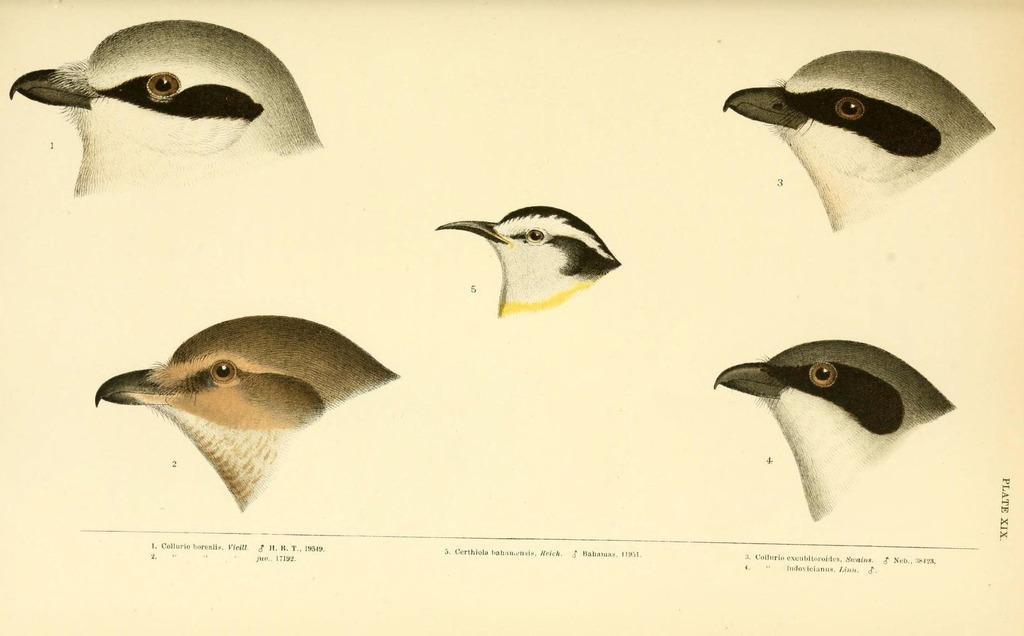What is depicted on the paper in the image? There are pictures of birds on a paper. What else can be seen on the paper besides the pictures of birds? There is text written on the paper. What type of attraction is visible in the image? There is no attraction present in the image; it features a paper with pictures of birds and text. Can you see a horn in the image? There is no horn present in the image. 